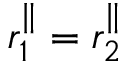Convert formula to latex. <formula><loc_0><loc_0><loc_500><loc_500>r _ { 1 } ^ { \| } = r _ { 2 } ^ { \| }</formula> 